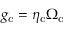Convert formula to latex. <formula><loc_0><loc_0><loc_500><loc_500>g _ { c } = \eta _ { c } \Omega _ { c }</formula> 